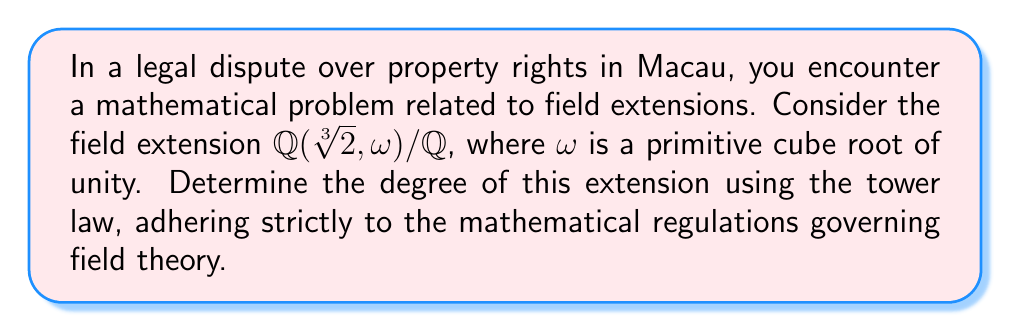Show me your answer to this math problem. To determine the degree of the field extension $\mathbb{Q}(\sqrt[3]{2}, \omega) / \mathbb{Q}$ using the tower law, we'll follow these steps:

1) First, consider the tower of extensions:
   $\mathbb{Q} \subset \mathbb{Q}(\omega) \subset \mathbb{Q}(\sqrt[3]{2}, \omega)$

2) By the tower law, we know that:
   $[\mathbb{Q}(\sqrt[3]{2}, \omega) : \mathbb{Q}] = [\mathbb{Q}(\sqrt[3]{2}, \omega) : \mathbb{Q}(\omega)] \cdot [\mathbb{Q}(\omega) : \mathbb{Q}]$

3) Let's determine $[\mathbb{Q}(\omega) : \mathbb{Q}]$:
   - $\omega$ is a primitive cube root of unity, so it satisfies $x^2 + x + 1 = 0$
   - This polynomial is irreducible over $\mathbb{Q}$
   - Therefore, $[\mathbb{Q}(\omega) : \mathbb{Q}] = 2$

4) Now, let's find $[\mathbb{Q}(\sqrt[3]{2}, \omega) : \mathbb{Q}(\omega)]$:
   - Over $\mathbb{Q}(\omega)$, $\sqrt[3]{2}$ satisfies $x^3 - 2 = 0$
   - This polynomial is irreducible over $\mathbb{Q}(\omega)$ (it has no rational or quadratic factors)
   - Thus, $[\mathbb{Q}(\sqrt[3]{2}, \omega) : \mathbb{Q}(\omega)] = 3$

5) Applying the tower law:
   $[\mathbb{Q}(\sqrt[3]{2}, \omega) : \mathbb{Q}] = 3 \cdot 2 = 6$

Therefore, the degree of the extension $\mathbb{Q}(\sqrt[3]{2}, \omega) / \mathbb{Q}$ is 6.
Answer: 6 